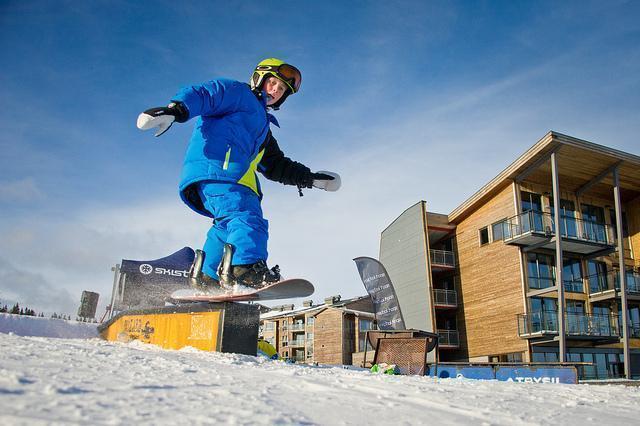Where is the boy playing at?
Answer the question by selecting the correct answer among the 4 following choices.
Options: Mountain, resort area, ski resort, neighborhood. Neighborhood. 